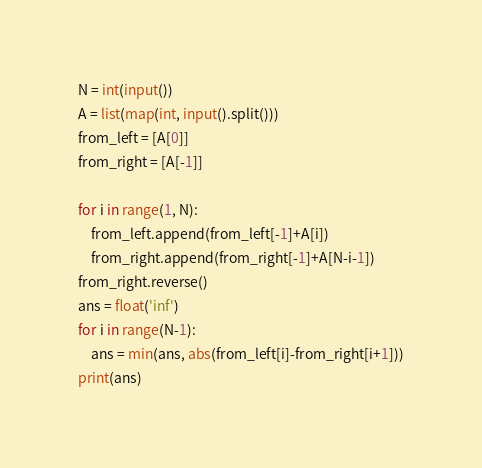<code> <loc_0><loc_0><loc_500><loc_500><_Python_>N = int(input())
A = list(map(int, input().split()))
from_left = [A[0]]
from_right = [A[-1]]

for i in range(1, N):
    from_left.append(from_left[-1]+A[i])
    from_right.append(from_right[-1]+A[N-i-1])
from_right.reverse()
ans = float('inf')
for i in range(N-1):
    ans = min(ans, abs(from_left[i]-from_right[i+1]))
print(ans)
</code> 